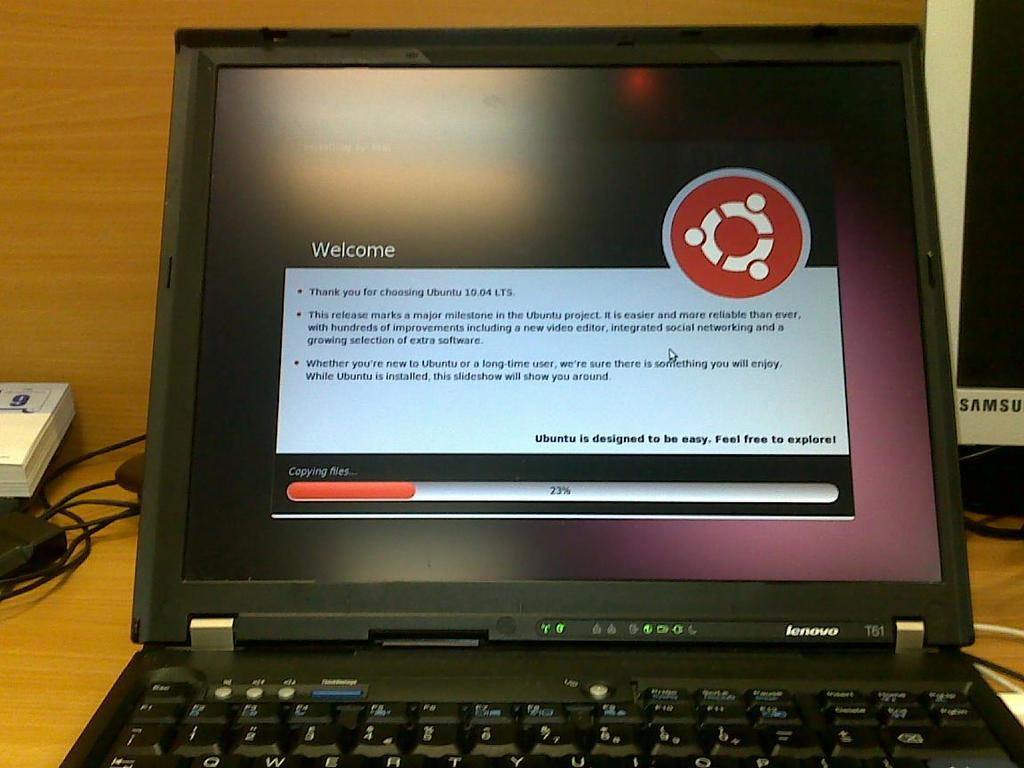<image>
Write a terse but informative summary of the picture. A laptop with a welcome screen for Ubuntu with an orange loading bar at the bottom. 